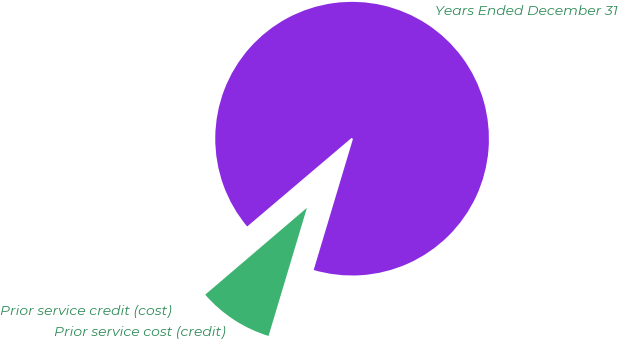<chart> <loc_0><loc_0><loc_500><loc_500><pie_chart><fcel>Years Ended December 31<fcel>Prior service credit (cost)<fcel>Prior service cost (credit)<nl><fcel>90.83%<fcel>0.05%<fcel>9.12%<nl></chart> 